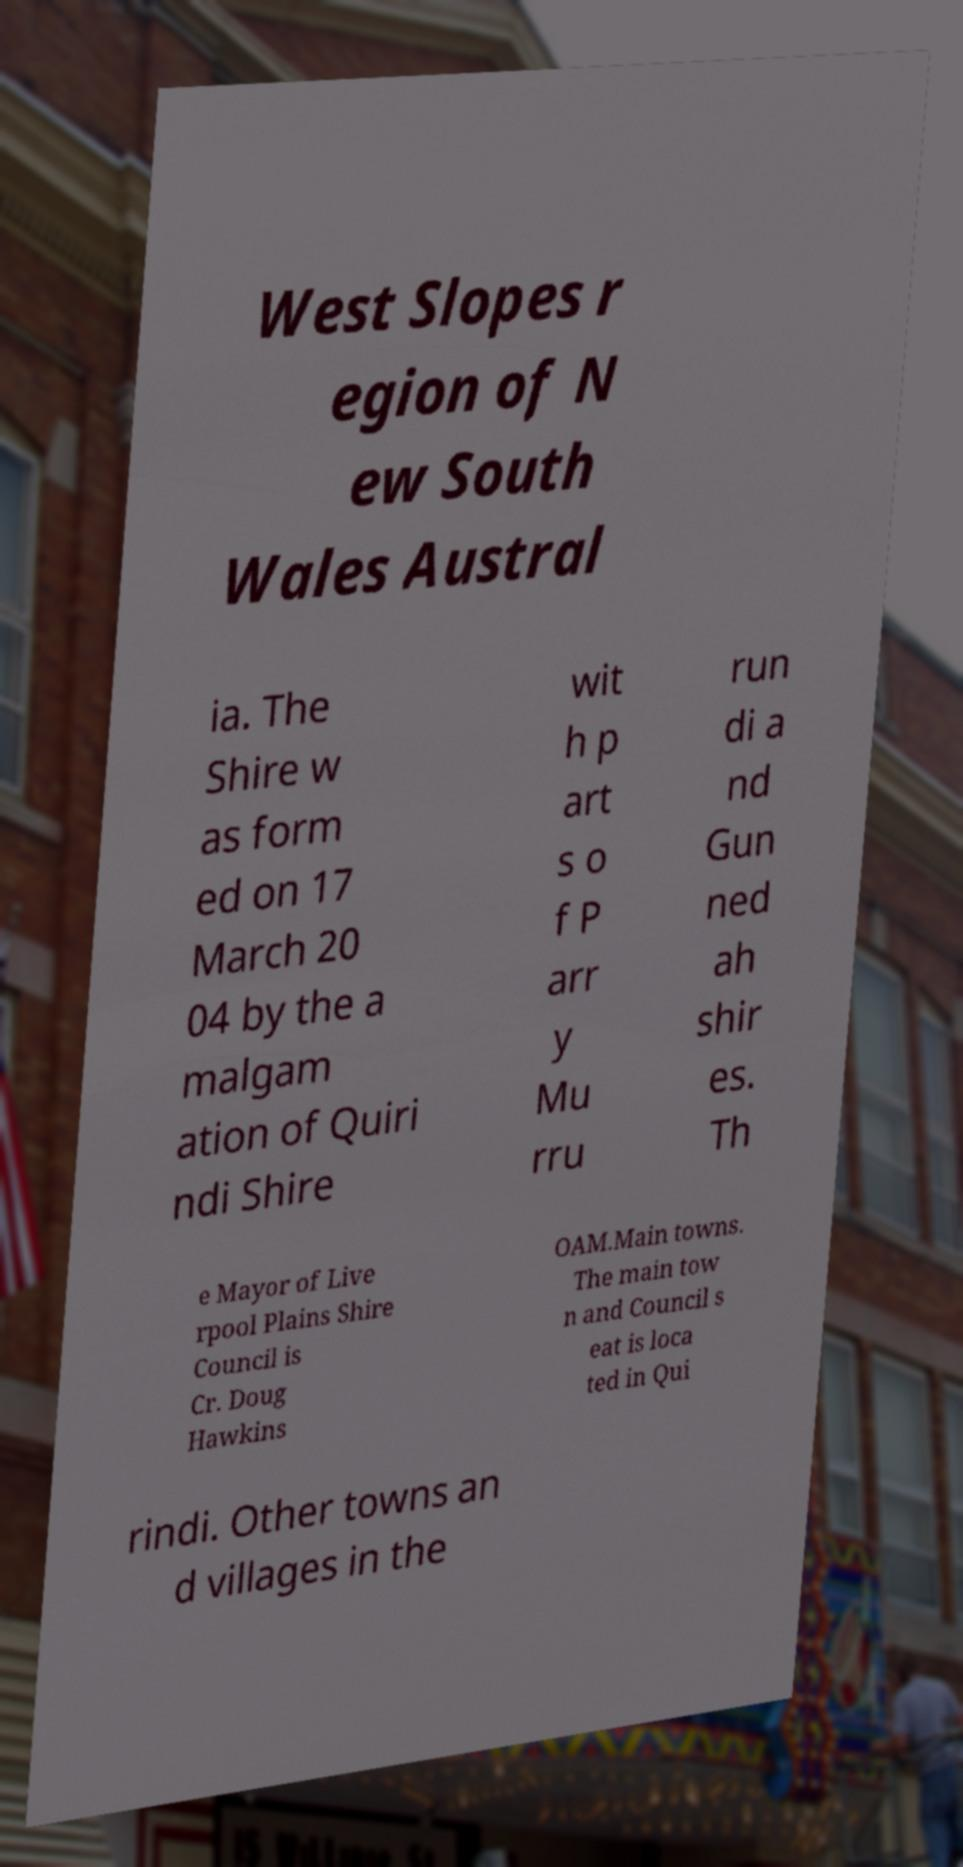There's text embedded in this image that I need extracted. Can you transcribe it verbatim? West Slopes r egion of N ew South Wales Austral ia. The Shire w as form ed on 17 March 20 04 by the a malgam ation of Quiri ndi Shire wit h p art s o f P arr y Mu rru run di a nd Gun ned ah shir es. Th e Mayor of Live rpool Plains Shire Council is Cr. Doug Hawkins OAM.Main towns. The main tow n and Council s eat is loca ted in Qui rindi. Other towns an d villages in the 